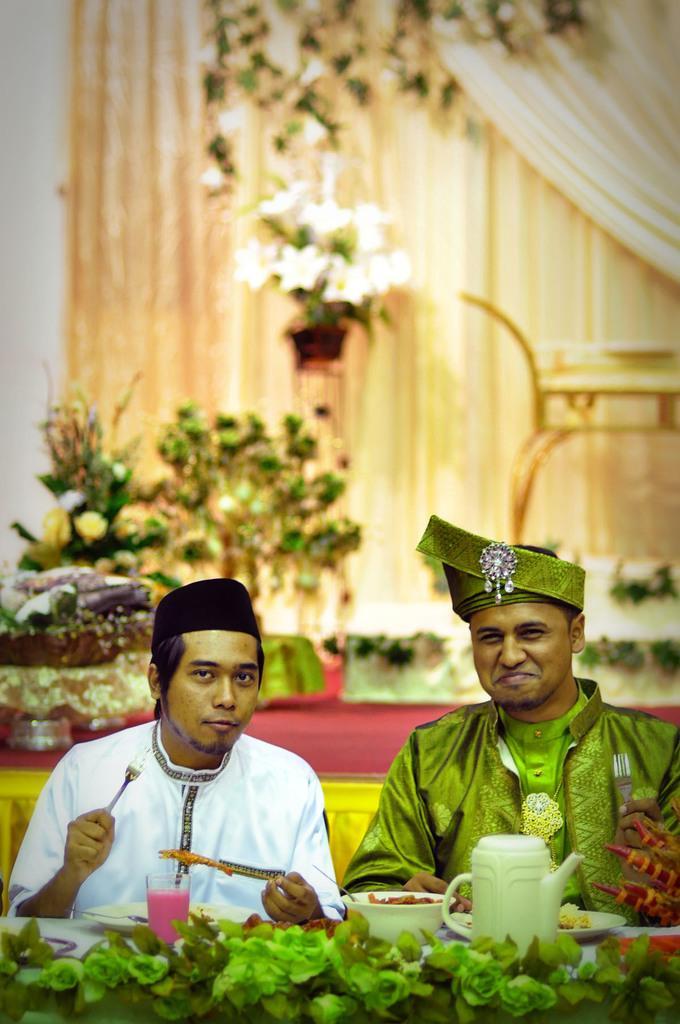Describe this image in one or two sentences. In this image I can see two persons are sitting on the chairs in front of a table on which I can see plates, glasses, bowl and a kettle. In the background I can see houseplants, wall and a curtain. This image is taken in a hall. 